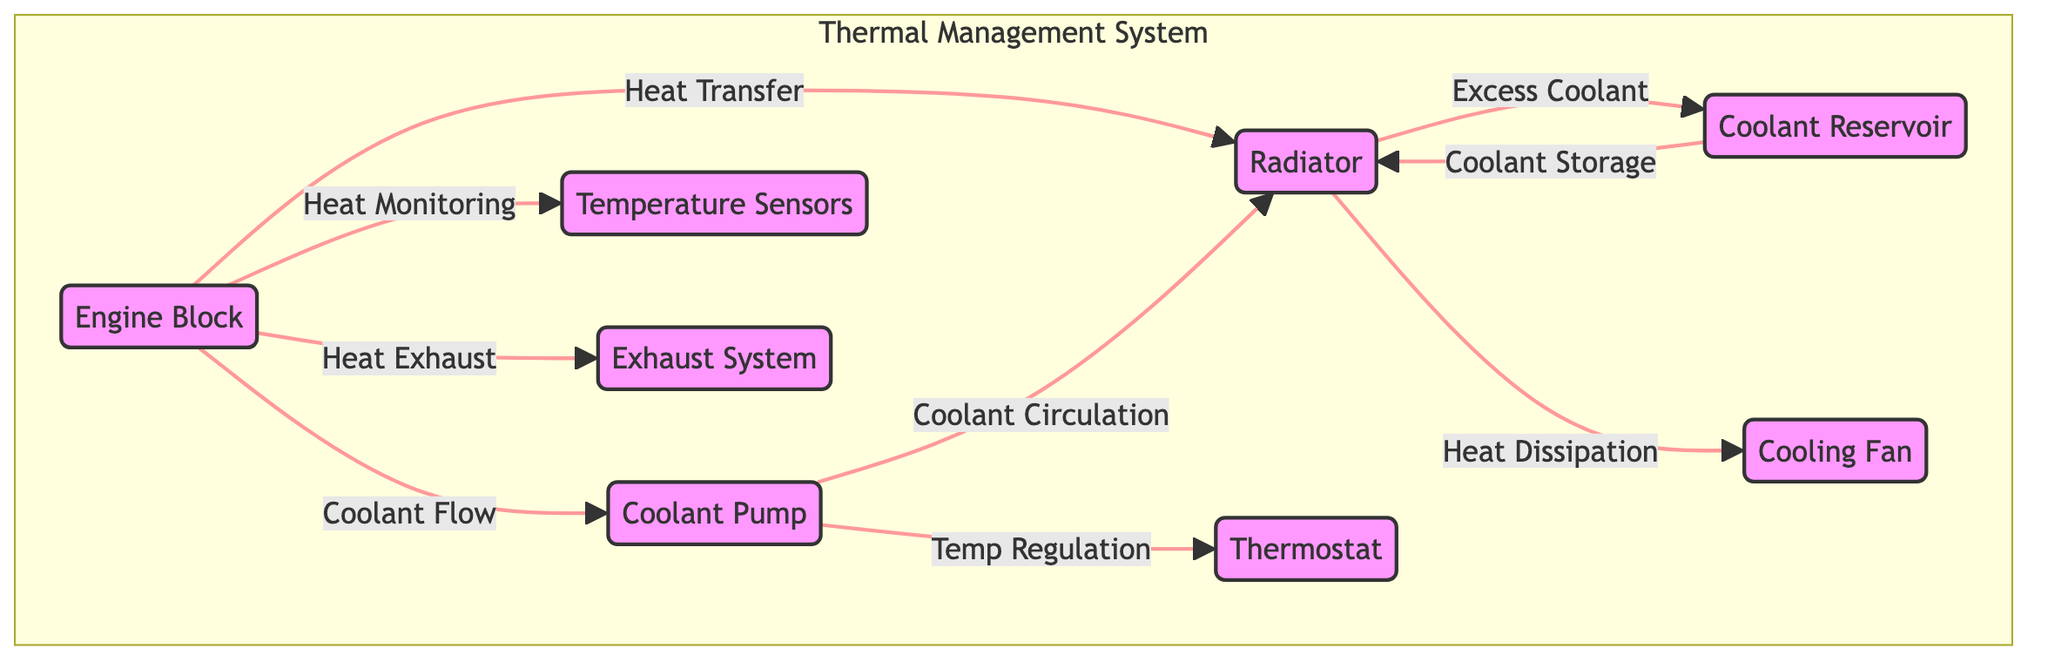What is the main component that directly dissipates heat? In the diagram, the arrow labeled "Heat Dissipation" points from the radiator to the fan, indicating that the radiator is responsible for dissipating heat.
Answer: Radiator How many components are in the Thermal Management System? The diagram contains seven components, which are demarcated within the "Thermal Management System" subgraph. These are the engine block, radiator, coolant pump, thermostat, coolant reservoir, temperature sensors, exhaust system, and fan.
Answer: Seven What is the relationship between the engine block and the coolant pump? The diagram shows the relationship labeled "Coolant Flow" arrows directed from the engine block leading to the coolant pump, indicating that the engine block is the starting point for coolant flow into the coolant pump.
Answer: Coolant Flow Which component is responsible for coolant storage? The arrow labeled "Coolant Storage" leads into the radiator from the coolant reservoir, indicating that the radiator is where coolant is stored after being pumped.
Answer: Radiator What is the primary function of the thermostat in this system? The diagram shows that the coolant pump connects to the thermostat through the labeled flow "Temp Regulation," indicating that the thermostat regulates temperature in the cooling system.
Answer: Temp Regulation Which component does the exhaust system connect to in the heat management process? The diagram indicates that the engine block directly leads to the exhaust system through the labeled flow "Heat Exhaust," showing that the exhaust system handles the heat expelled by the engine.
Answer: Engine Block What component monitors the heat in the engine block? The arrow labeled "Heat Monitoring" points from the engine block to the temperature sensors, showing that temperature sensors are responsible for monitoring heat levels in the engine block.
Answer: Temperature Sensors What is the purpose of the fan in the system? The diagram details that the fan is connected to the radiator through the flow labeled "Heat Dissipation," indicating that the fan's purpose is to assist in dissipating heat away from the radiator.
Answer: Assist in dissipating heat How does the radiator receive excess coolant? The diagram shows that the relationship labeled "Excess Coolant" flows from the radiator to the coolant reservoir, indicating this flow represents the return of excess coolant back to the coolant reservoir for storage.
Answer: From the radiator to the coolant reservoir 